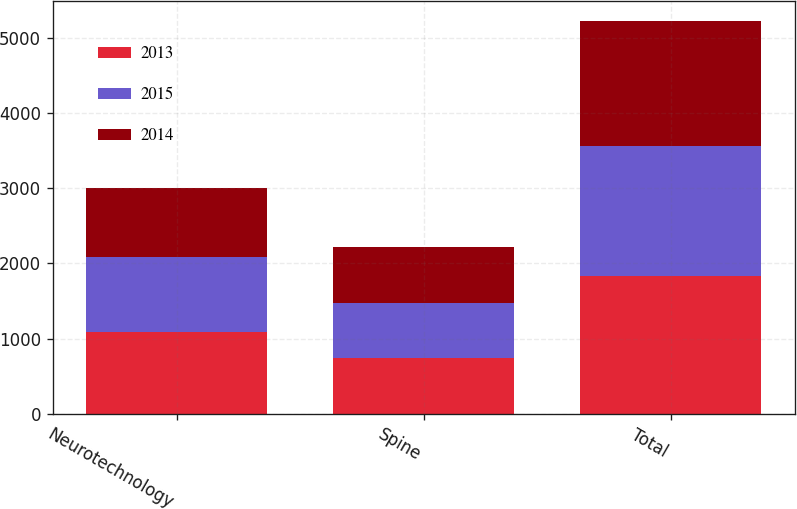<chart> <loc_0><loc_0><loc_500><loc_500><stacked_bar_chart><ecel><fcel>Neurotechnology<fcel>Spine<fcel>Total<nl><fcel>2013<fcel>1088<fcel>740<fcel>1828<nl><fcel>2015<fcel>1001<fcel>740<fcel>1741<nl><fcel>2014<fcel>915<fcel>743<fcel>1658<nl></chart> 